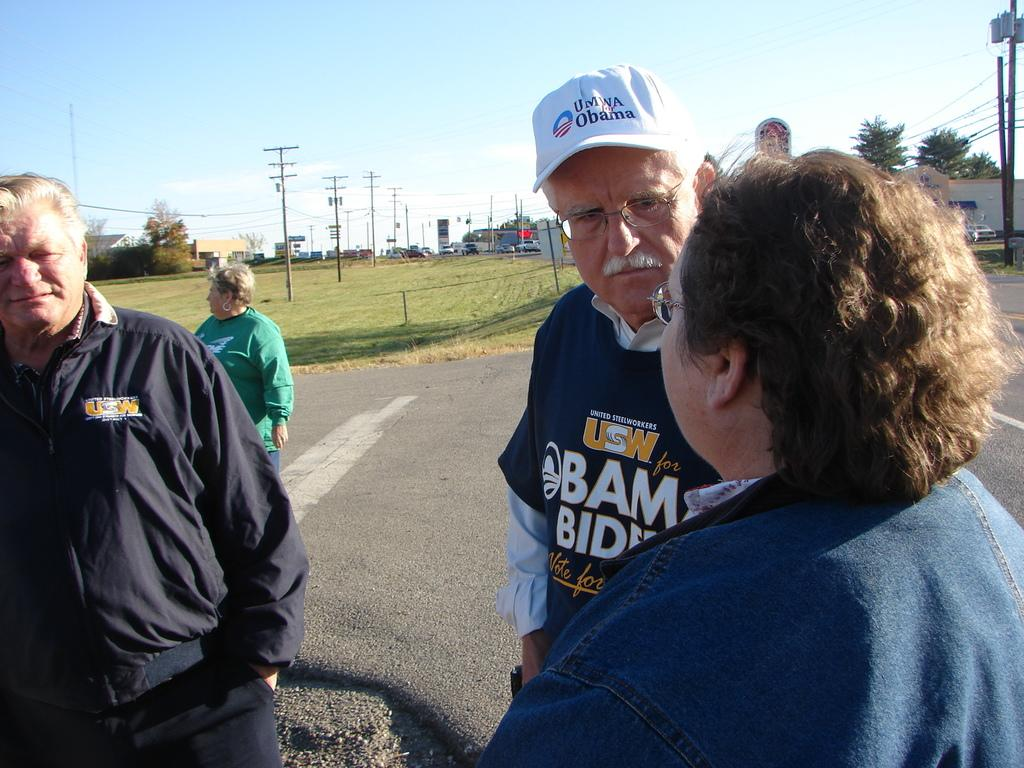What can be seen in front of the people in the image? There are people standing in front of the image. What is the surface behind the people made of? There is grass on the surface behind the people. What structures are present with cables in the image? There are electric poles with cables in the image. What type of natural scenery is visible in the background? There are trees in the background. What type of man-made structures can be seen in the background? There are buildings in the background. What type of cork can be seen rolling down the slope in the image? There is no cork or slope present in the image; it features people standing on grass with electric poles and background scenery. 